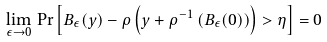<formula> <loc_0><loc_0><loc_500><loc_500>\lim _ { \epsilon \to 0 } \, \Pr \left [ B _ { \epsilon } ( y ) - \rho \left ( y + \rho ^ { - 1 } \left ( B _ { \epsilon } ( 0 ) \right ) \right ) > \eta \right ] = 0</formula> 